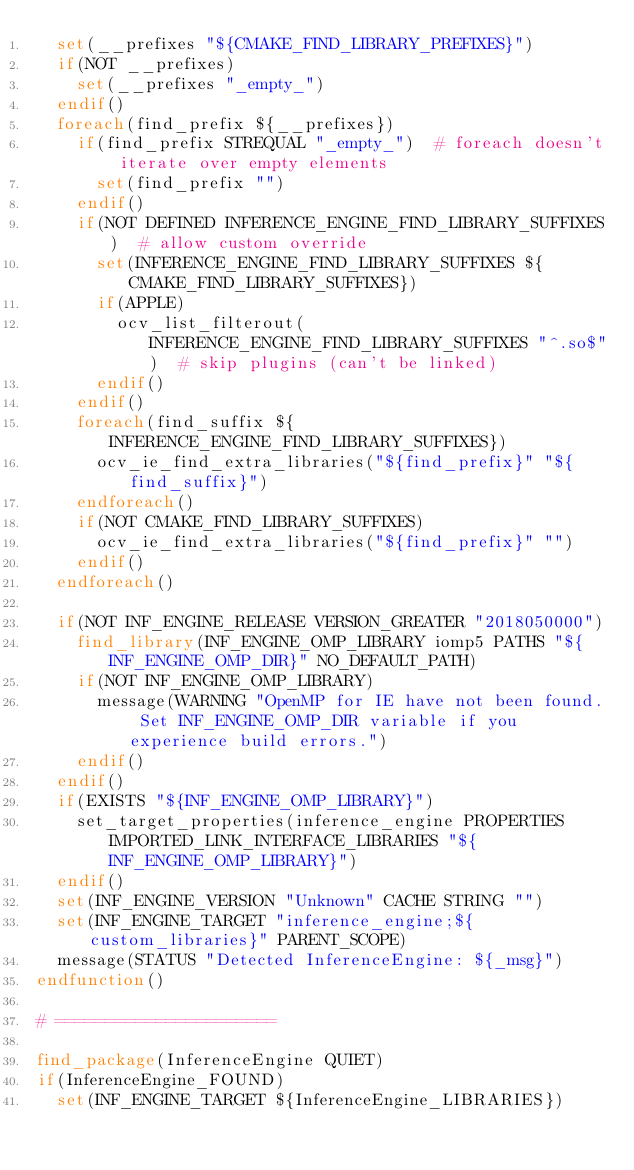<code> <loc_0><loc_0><loc_500><loc_500><_CMake_>  set(__prefixes "${CMAKE_FIND_LIBRARY_PREFIXES}")
  if(NOT __prefixes)
    set(__prefixes "_empty_")
  endif()
  foreach(find_prefix ${__prefixes})
    if(find_prefix STREQUAL "_empty_")  # foreach doesn't iterate over empty elements
      set(find_prefix "")
    endif()
    if(NOT DEFINED INFERENCE_ENGINE_FIND_LIBRARY_SUFFIXES)  # allow custom override
      set(INFERENCE_ENGINE_FIND_LIBRARY_SUFFIXES ${CMAKE_FIND_LIBRARY_SUFFIXES})
      if(APPLE)
        ocv_list_filterout(INFERENCE_ENGINE_FIND_LIBRARY_SUFFIXES "^.so$")  # skip plugins (can't be linked)
      endif()
    endif()
    foreach(find_suffix ${INFERENCE_ENGINE_FIND_LIBRARY_SUFFIXES})
      ocv_ie_find_extra_libraries("${find_prefix}" "${find_suffix}")
    endforeach()
    if(NOT CMAKE_FIND_LIBRARY_SUFFIXES)
      ocv_ie_find_extra_libraries("${find_prefix}" "")
    endif()
  endforeach()

  if(NOT INF_ENGINE_RELEASE VERSION_GREATER "2018050000")
    find_library(INF_ENGINE_OMP_LIBRARY iomp5 PATHS "${INF_ENGINE_OMP_DIR}" NO_DEFAULT_PATH)
    if(NOT INF_ENGINE_OMP_LIBRARY)
      message(WARNING "OpenMP for IE have not been found. Set INF_ENGINE_OMP_DIR variable if you experience build errors.")
    endif()
  endif()
  if(EXISTS "${INF_ENGINE_OMP_LIBRARY}")
    set_target_properties(inference_engine PROPERTIES IMPORTED_LINK_INTERFACE_LIBRARIES "${INF_ENGINE_OMP_LIBRARY}")
  endif()
  set(INF_ENGINE_VERSION "Unknown" CACHE STRING "")
  set(INF_ENGINE_TARGET "inference_engine;${custom_libraries}" PARENT_SCOPE)
  message(STATUS "Detected InferenceEngine: ${_msg}")
endfunction()

# ======================

find_package(InferenceEngine QUIET)
if(InferenceEngine_FOUND)
  set(INF_ENGINE_TARGET ${InferenceEngine_LIBRARIES})</code> 